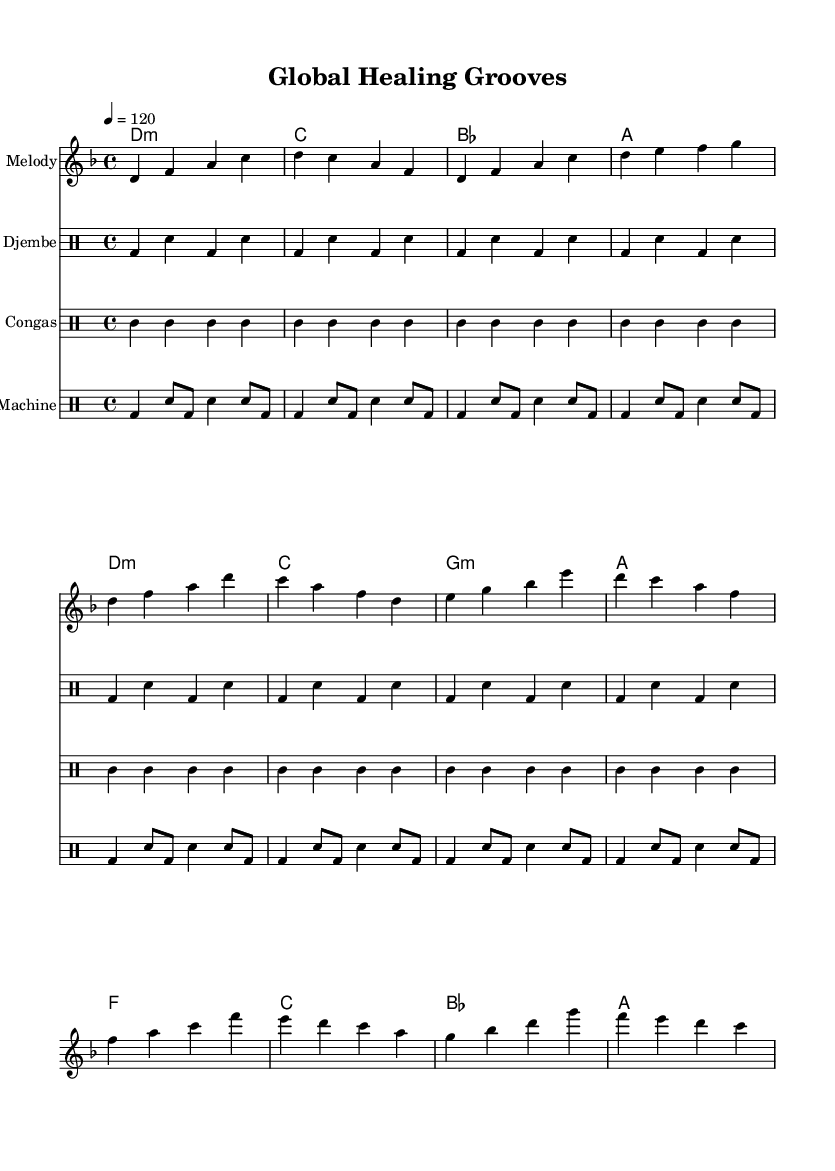What is the key signature of this music? The key signature is indicated by the second to last flat on the staff. Since there are no sharps or flats in the key signature, the key is D minor.
Answer: D minor What is the time signature of this piece? The time signature is found at the beginning of the score, indicated as 4/4, meaning there are four beats in each measure and the quarter note gets one beat.
Answer: 4/4 What is the tempo marking in the score? The tempo is marked at the beginning with "4 = 120", which means there are 120 beats per minute. Thus, the tempo is set to a moderate pace.
Answer: 120 Which instruments are featured in this composition? The instruments are listed at the beginning of their respective staves in the score. The composition includes Melody, Djembe, Congas, and Drum Machine.
Answer: Melody, Djembe, Congas, Drum Machine How many measures are in the intro section? The intro section can be identified within the melody part. It contains a total of 4 measures, following the introductory notation.
Answer: 4 What kind of rhythms are indicated for the Djembe in this music? The Djembe part features a recurring rhythm with a clear pattern represented as bass and snare hits. The specific notation indicates a rhythmic cycle that is repeated.
Answer: Bass and snare What cultural element does this piece celebrate? The music and title indicate a celebration of cultural diversity through the fusion of world music and dance rhythms, embodied in the composition's overall theme.
Answer: Cultural diversity 